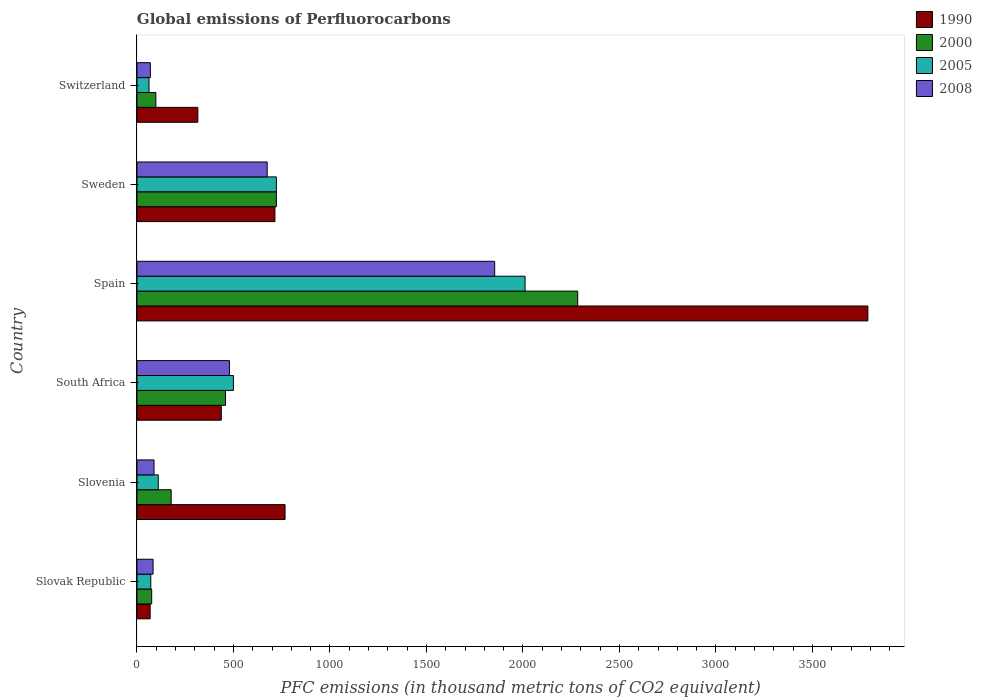How many groups of bars are there?
Your answer should be compact. 6. Are the number of bars per tick equal to the number of legend labels?
Ensure brevity in your answer.  Yes. Are the number of bars on each tick of the Y-axis equal?
Your answer should be compact. Yes. How many bars are there on the 1st tick from the top?
Provide a short and direct response. 4. How many bars are there on the 3rd tick from the bottom?
Provide a short and direct response. 4. In how many cases, is the number of bars for a given country not equal to the number of legend labels?
Provide a short and direct response. 0. What is the global emissions of Perfluorocarbons in 2005 in Slovenia?
Keep it short and to the point. 110.3. Across all countries, what is the maximum global emissions of Perfluorocarbons in 2005?
Offer a terse response. 2011. Across all countries, what is the minimum global emissions of Perfluorocarbons in 2008?
Make the answer very short. 69.4. In which country was the global emissions of Perfluorocarbons in 2008 minimum?
Provide a short and direct response. Switzerland. What is the total global emissions of Perfluorocarbons in 2008 in the graph?
Your answer should be compact. 3248.8. What is the difference between the global emissions of Perfluorocarbons in 1990 in South Africa and that in Sweden?
Your answer should be very brief. -277.9. What is the difference between the global emissions of Perfluorocarbons in 2005 in Sweden and the global emissions of Perfluorocarbons in 1990 in Slovak Republic?
Give a very brief answer. 654. What is the average global emissions of Perfluorocarbons in 1990 per country?
Your answer should be compact. 1015.08. What is the difference between the global emissions of Perfluorocarbons in 2005 and global emissions of Perfluorocarbons in 2000 in Switzerland?
Your response must be concise. -35.4. In how many countries, is the global emissions of Perfluorocarbons in 2008 greater than 3300 thousand metric tons?
Provide a short and direct response. 0. What is the ratio of the global emissions of Perfluorocarbons in 2005 in Slovak Republic to that in Slovenia?
Offer a terse response. 0.65. Is the global emissions of Perfluorocarbons in 2008 in Slovenia less than that in Spain?
Provide a succinct answer. Yes. What is the difference between the highest and the second highest global emissions of Perfluorocarbons in 2005?
Offer a very short reply. 1288.7. What is the difference between the highest and the lowest global emissions of Perfluorocarbons in 2005?
Offer a terse response. 1948.5. Is the sum of the global emissions of Perfluorocarbons in 2008 in Slovak Republic and Spain greater than the maximum global emissions of Perfluorocarbons in 1990 across all countries?
Give a very brief answer. No. What does the 1st bar from the bottom in Slovak Republic represents?
Make the answer very short. 1990. How many bars are there?
Make the answer very short. 24. Are all the bars in the graph horizontal?
Provide a short and direct response. Yes. How many countries are there in the graph?
Your response must be concise. 6. What is the difference between two consecutive major ticks on the X-axis?
Your answer should be very brief. 500. Does the graph contain any zero values?
Your answer should be very brief. No. How many legend labels are there?
Make the answer very short. 4. How are the legend labels stacked?
Keep it short and to the point. Vertical. What is the title of the graph?
Ensure brevity in your answer.  Global emissions of Perfluorocarbons. Does "2012" appear as one of the legend labels in the graph?
Provide a succinct answer. No. What is the label or title of the X-axis?
Offer a terse response. PFC emissions (in thousand metric tons of CO2 equivalent). What is the label or title of the Y-axis?
Make the answer very short. Country. What is the PFC emissions (in thousand metric tons of CO2 equivalent) of 1990 in Slovak Republic?
Offer a terse response. 68.3. What is the PFC emissions (in thousand metric tons of CO2 equivalent) in 2000 in Slovak Republic?
Give a very brief answer. 76.3. What is the PFC emissions (in thousand metric tons of CO2 equivalent) of 2005 in Slovak Republic?
Make the answer very short. 71.6. What is the PFC emissions (in thousand metric tons of CO2 equivalent) in 2008 in Slovak Republic?
Your answer should be very brief. 83.5. What is the PFC emissions (in thousand metric tons of CO2 equivalent) in 1990 in Slovenia?
Ensure brevity in your answer.  767.4. What is the PFC emissions (in thousand metric tons of CO2 equivalent) in 2000 in Slovenia?
Your answer should be very brief. 177.2. What is the PFC emissions (in thousand metric tons of CO2 equivalent) of 2005 in Slovenia?
Your response must be concise. 110.3. What is the PFC emissions (in thousand metric tons of CO2 equivalent) in 2008 in Slovenia?
Make the answer very short. 88.4. What is the PFC emissions (in thousand metric tons of CO2 equivalent) of 1990 in South Africa?
Your answer should be compact. 437. What is the PFC emissions (in thousand metric tons of CO2 equivalent) of 2000 in South Africa?
Offer a terse response. 458.8. What is the PFC emissions (in thousand metric tons of CO2 equivalent) of 2005 in South Africa?
Offer a very short reply. 499.8. What is the PFC emissions (in thousand metric tons of CO2 equivalent) in 2008 in South Africa?
Make the answer very short. 479.2. What is the PFC emissions (in thousand metric tons of CO2 equivalent) of 1990 in Spain?
Keep it short and to the point. 3787.4. What is the PFC emissions (in thousand metric tons of CO2 equivalent) in 2000 in Spain?
Make the answer very short. 2283.8. What is the PFC emissions (in thousand metric tons of CO2 equivalent) of 2005 in Spain?
Your answer should be compact. 2011. What is the PFC emissions (in thousand metric tons of CO2 equivalent) of 2008 in Spain?
Give a very brief answer. 1853.5. What is the PFC emissions (in thousand metric tons of CO2 equivalent) in 1990 in Sweden?
Provide a short and direct response. 714.9. What is the PFC emissions (in thousand metric tons of CO2 equivalent) in 2000 in Sweden?
Provide a short and direct response. 722.5. What is the PFC emissions (in thousand metric tons of CO2 equivalent) of 2005 in Sweden?
Keep it short and to the point. 722.3. What is the PFC emissions (in thousand metric tons of CO2 equivalent) in 2008 in Sweden?
Offer a terse response. 674.8. What is the PFC emissions (in thousand metric tons of CO2 equivalent) in 1990 in Switzerland?
Your answer should be compact. 315.5. What is the PFC emissions (in thousand metric tons of CO2 equivalent) of 2000 in Switzerland?
Offer a terse response. 97.9. What is the PFC emissions (in thousand metric tons of CO2 equivalent) of 2005 in Switzerland?
Make the answer very short. 62.5. What is the PFC emissions (in thousand metric tons of CO2 equivalent) of 2008 in Switzerland?
Your answer should be compact. 69.4. Across all countries, what is the maximum PFC emissions (in thousand metric tons of CO2 equivalent) in 1990?
Offer a terse response. 3787.4. Across all countries, what is the maximum PFC emissions (in thousand metric tons of CO2 equivalent) of 2000?
Give a very brief answer. 2283.8. Across all countries, what is the maximum PFC emissions (in thousand metric tons of CO2 equivalent) of 2005?
Your answer should be very brief. 2011. Across all countries, what is the maximum PFC emissions (in thousand metric tons of CO2 equivalent) in 2008?
Give a very brief answer. 1853.5. Across all countries, what is the minimum PFC emissions (in thousand metric tons of CO2 equivalent) in 1990?
Your answer should be very brief. 68.3. Across all countries, what is the minimum PFC emissions (in thousand metric tons of CO2 equivalent) in 2000?
Your answer should be very brief. 76.3. Across all countries, what is the minimum PFC emissions (in thousand metric tons of CO2 equivalent) in 2005?
Provide a succinct answer. 62.5. Across all countries, what is the minimum PFC emissions (in thousand metric tons of CO2 equivalent) in 2008?
Offer a very short reply. 69.4. What is the total PFC emissions (in thousand metric tons of CO2 equivalent) of 1990 in the graph?
Your answer should be very brief. 6090.5. What is the total PFC emissions (in thousand metric tons of CO2 equivalent) in 2000 in the graph?
Ensure brevity in your answer.  3816.5. What is the total PFC emissions (in thousand metric tons of CO2 equivalent) of 2005 in the graph?
Make the answer very short. 3477.5. What is the total PFC emissions (in thousand metric tons of CO2 equivalent) in 2008 in the graph?
Ensure brevity in your answer.  3248.8. What is the difference between the PFC emissions (in thousand metric tons of CO2 equivalent) of 1990 in Slovak Republic and that in Slovenia?
Offer a very short reply. -699.1. What is the difference between the PFC emissions (in thousand metric tons of CO2 equivalent) in 2000 in Slovak Republic and that in Slovenia?
Give a very brief answer. -100.9. What is the difference between the PFC emissions (in thousand metric tons of CO2 equivalent) of 2005 in Slovak Republic and that in Slovenia?
Make the answer very short. -38.7. What is the difference between the PFC emissions (in thousand metric tons of CO2 equivalent) of 1990 in Slovak Republic and that in South Africa?
Make the answer very short. -368.7. What is the difference between the PFC emissions (in thousand metric tons of CO2 equivalent) of 2000 in Slovak Republic and that in South Africa?
Your response must be concise. -382.5. What is the difference between the PFC emissions (in thousand metric tons of CO2 equivalent) in 2005 in Slovak Republic and that in South Africa?
Your answer should be very brief. -428.2. What is the difference between the PFC emissions (in thousand metric tons of CO2 equivalent) of 2008 in Slovak Republic and that in South Africa?
Ensure brevity in your answer.  -395.7. What is the difference between the PFC emissions (in thousand metric tons of CO2 equivalent) of 1990 in Slovak Republic and that in Spain?
Offer a terse response. -3719.1. What is the difference between the PFC emissions (in thousand metric tons of CO2 equivalent) of 2000 in Slovak Republic and that in Spain?
Offer a terse response. -2207.5. What is the difference between the PFC emissions (in thousand metric tons of CO2 equivalent) of 2005 in Slovak Republic and that in Spain?
Offer a terse response. -1939.4. What is the difference between the PFC emissions (in thousand metric tons of CO2 equivalent) in 2008 in Slovak Republic and that in Spain?
Ensure brevity in your answer.  -1770. What is the difference between the PFC emissions (in thousand metric tons of CO2 equivalent) of 1990 in Slovak Republic and that in Sweden?
Offer a very short reply. -646.6. What is the difference between the PFC emissions (in thousand metric tons of CO2 equivalent) of 2000 in Slovak Republic and that in Sweden?
Offer a very short reply. -646.2. What is the difference between the PFC emissions (in thousand metric tons of CO2 equivalent) in 2005 in Slovak Republic and that in Sweden?
Offer a very short reply. -650.7. What is the difference between the PFC emissions (in thousand metric tons of CO2 equivalent) in 2008 in Slovak Republic and that in Sweden?
Your response must be concise. -591.3. What is the difference between the PFC emissions (in thousand metric tons of CO2 equivalent) in 1990 in Slovak Republic and that in Switzerland?
Offer a very short reply. -247.2. What is the difference between the PFC emissions (in thousand metric tons of CO2 equivalent) in 2000 in Slovak Republic and that in Switzerland?
Make the answer very short. -21.6. What is the difference between the PFC emissions (in thousand metric tons of CO2 equivalent) in 2008 in Slovak Republic and that in Switzerland?
Provide a short and direct response. 14.1. What is the difference between the PFC emissions (in thousand metric tons of CO2 equivalent) in 1990 in Slovenia and that in South Africa?
Provide a succinct answer. 330.4. What is the difference between the PFC emissions (in thousand metric tons of CO2 equivalent) of 2000 in Slovenia and that in South Africa?
Your response must be concise. -281.6. What is the difference between the PFC emissions (in thousand metric tons of CO2 equivalent) of 2005 in Slovenia and that in South Africa?
Keep it short and to the point. -389.5. What is the difference between the PFC emissions (in thousand metric tons of CO2 equivalent) of 2008 in Slovenia and that in South Africa?
Keep it short and to the point. -390.8. What is the difference between the PFC emissions (in thousand metric tons of CO2 equivalent) of 1990 in Slovenia and that in Spain?
Keep it short and to the point. -3020. What is the difference between the PFC emissions (in thousand metric tons of CO2 equivalent) of 2000 in Slovenia and that in Spain?
Offer a terse response. -2106.6. What is the difference between the PFC emissions (in thousand metric tons of CO2 equivalent) in 2005 in Slovenia and that in Spain?
Give a very brief answer. -1900.7. What is the difference between the PFC emissions (in thousand metric tons of CO2 equivalent) of 2008 in Slovenia and that in Spain?
Keep it short and to the point. -1765.1. What is the difference between the PFC emissions (in thousand metric tons of CO2 equivalent) of 1990 in Slovenia and that in Sweden?
Offer a terse response. 52.5. What is the difference between the PFC emissions (in thousand metric tons of CO2 equivalent) in 2000 in Slovenia and that in Sweden?
Offer a very short reply. -545.3. What is the difference between the PFC emissions (in thousand metric tons of CO2 equivalent) of 2005 in Slovenia and that in Sweden?
Provide a short and direct response. -612. What is the difference between the PFC emissions (in thousand metric tons of CO2 equivalent) of 2008 in Slovenia and that in Sweden?
Provide a succinct answer. -586.4. What is the difference between the PFC emissions (in thousand metric tons of CO2 equivalent) of 1990 in Slovenia and that in Switzerland?
Your answer should be compact. 451.9. What is the difference between the PFC emissions (in thousand metric tons of CO2 equivalent) of 2000 in Slovenia and that in Switzerland?
Your answer should be compact. 79.3. What is the difference between the PFC emissions (in thousand metric tons of CO2 equivalent) of 2005 in Slovenia and that in Switzerland?
Make the answer very short. 47.8. What is the difference between the PFC emissions (in thousand metric tons of CO2 equivalent) in 1990 in South Africa and that in Spain?
Provide a succinct answer. -3350.4. What is the difference between the PFC emissions (in thousand metric tons of CO2 equivalent) of 2000 in South Africa and that in Spain?
Ensure brevity in your answer.  -1825. What is the difference between the PFC emissions (in thousand metric tons of CO2 equivalent) in 2005 in South Africa and that in Spain?
Provide a succinct answer. -1511.2. What is the difference between the PFC emissions (in thousand metric tons of CO2 equivalent) in 2008 in South Africa and that in Spain?
Keep it short and to the point. -1374.3. What is the difference between the PFC emissions (in thousand metric tons of CO2 equivalent) in 1990 in South Africa and that in Sweden?
Offer a very short reply. -277.9. What is the difference between the PFC emissions (in thousand metric tons of CO2 equivalent) of 2000 in South Africa and that in Sweden?
Provide a succinct answer. -263.7. What is the difference between the PFC emissions (in thousand metric tons of CO2 equivalent) in 2005 in South Africa and that in Sweden?
Offer a terse response. -222.5. What is the difference between the PFC emissions (in thousand metric tons of CO2 equivalent) in 2008 in South Africa and that in Sweden?
Offer a terse response. -195.6. What is the difference between the PFC emissions (in thousand metric tons of CO2 equivalent) of 1990 in South Africa and that in Switzerland?
Offer a very short reply. 121.5. What is the difference between the PFC emissions (in thousand metric tons of CO2 equivalent) of 2000 in South Africa and that in Switzerland?
Make the answer very short. 360.9. What is the difference between the PFC emissions (in thousand metric tons of CO2 equivalent) in 2005 in South Africa and that in Switzerland?
Provide a short and direct response. 437.3. What is the difference between the PFC emissions (in thousand metric tons of CO2 equivalent) in 2008 in South Africa and that in Switzerland?
Your response must be concise. 409.8. What is the difference between the PFC emissions (in thousand metric tons of CO2 equivalent) of 1990 in Spain and that in Sweden?
Provide a short and direct response. 3072.5. What is the difference between the PFC emissions (in thousand metric tons of CO2 equivalent) in 2000 in Spain and that in Sweden?
Provide a succinct answer. 1561.3. What is the difference between the PFC emissions (in thousand metric tons of CO2 equivalent) in 2005 in Spain and that in Sweden?
Your response must be concise. 1288.7. What is the difference between the PFC emissions (in thousand metric tons of CO2 equivalent) of 2008 in Spain and that in Sweden?
Offer a very short reply. 1178.7. What is the difference between the PFC emissions (in thousand metric tons of CO2 equivalent) of 1990 in Spain and that in Switzerland?
Your answer should be compact. 3471.9. What is the difference between the PFC emissions (in thousand metric tons of CO2 equivalent) in 2000 in Spain and that in Switzerland?
Your answer should be compact. 2185.9. What is the difference between the PFC emissions (in thousand metric tons of CO2 equivalent) of 2005 in Spain and that in Switzerland?
Ensure brevity in your answer.  1948.5. What is the difference between the PFC emissions (in thousand metric tons of CO2 equivalent) in 2008 in Spain and that in Switzerland?
Your answer should be very brief. 1784.1. What is the difference between the PFC emissions (in thousand metric tons of CO2 equivalent) of 1990 in Sweden and that in Switzerland?
Provide a short and direct response. 399.4. What is the difference between the PFC emissions (in thousand metric tons of CO2 equivalent) of 2000 in Sweden and that in Switzerland?
Provide a succinct answer. 624.6. What is the difference between the PFC emissions (in thousand metric tons of CO2 equivalent) of 2005 in Sweden and that in Switzerland?
Provide a short and direct response. 659.8. What is the difference between the PFC emissions (in thousand metric tons of CO2 equivalent) in 2008 in Sweden and that in Switzerland?
Your answer should be compact. 605.4. What is the difference between the PFC emissions (in thousand metric tons of CO2 equivalent) of 1990 in Slovak Republic and the PFC emissions (in thousand metric tons of CO2 equivalent) of 2000 in Slovenia?
Provide a succinct answer. -108.9. What is the difference between the PFC emissions (in thousand metric tons of CO2 equivalent) in 1990 in Slovak Republic and the PFC emissions (in thousand metric tons of CO2 equivalent) in 2005 in Slovenia?
Your answer should be very brief. -42. What is the difference between the PFC emissions (in thousand metric tons of CO2 equivalent) in 1990 in Slovak Republic and the PFC emissions (in thousand metric tons of CO2 equivalent) in 2008 in Slovenia?
Your response must be concise. -20.1. What is the difference between the PFC emissions (in thousand metric tons of CO2 equivalent) in 2000 in Slovak Republic and the PFC emissions (in thousand metric tons of CO2 equivalent) in 2005 in Slovenia?
Offer a very short reply. -34. What is the difference between the PFC emissions (in thousand metric tons of CO2 equivalent) in 2005 in Slovak Republic and the PFC emissions (in thousand metric tons of CO2 equivalent) in 2008 in Slovenia?
Your answer should be compact. -16.8. What is the difference between the PFC emissions (in thousand metric tons of CO2 equivalent) in 1990 in Slovak Republic and the PFC emissions (in thousand metric tons of CO2 equivalent) in 2000 in South Africa?
Make the answer very short. -390.5. What is the difference between the PFC emissions (in thousand metric tons of CO2 equivalent) of 1990 in Slovak Republic and the PFC emissions (in thousand metric tons of CO2 equivalent) of 2005 in South Africa?
Offer a very short reply. -431.5. What is the difference between the PFC emissions (in thousand metric tons of CO2 equivalent) of 1990 in Slovak Republic and the PFC emissions (in thousand metric tons of CO2 equivalent) of 2008 in South Africa?
Offer a terse response. -410.9. What is the difference between the PFC emissions (in thousand metric tons of CO2 equivalent) of 2000 in Slovak Republic and the PFC emissions (in thousand metric tons of CO2 equivalent) of 2005 in South Africa?
Offer a terse response. -423.5. What is the difference between the PFC emissions (in thousand metric tons of CO2 equivalent) of 2000 in Slovak Republic and the PFC emissions (in thousand metric tons of CO2 equivalent) of 2008 in South Africa?
Offer a terse response. -402.9. What is the difference between the PFC emissions (in thousand metric tons of CO2 equivalent) in 2005 in Slovak Republic and the PFC emissions (in thousand metric tons of CO2 equivalent) in 2008 in South Africa?
Offer a terse response. -407.6. What is the difference between the PFC emissions (in thousand metric tons of CO2 equivalent) in 1990 in Slovak Republic and the PFC emissions (in thousand metric tons of CO2 equivalent) in 2000 in Spain?
Your response must be concise. -2215.5. What is the difference between the PFC emissions (in thousand metric tons of CO2 equivalent) of 1990 in Slovak Republic and the PFC emissions (in thousand metric tons of CO2 equivalent) of 2005 in Spain?
Keep it short and to the point. -1942.7. What is the difference between the PFC emissions (in thousand metric tons of CO2 equivalent) of 1990 in Slovak Republic and the PFC emissions (in thousand metric tons of CO2 equivalent) of 2008 in Spain?
Give a very brief answer. -1785.2. What is the difference between the PFC emissions (in thousand metric tons of CO2 equivalent) in 2000 in Slovak Republic and the PFC emissions (in thousand metric tons of CO2 equivalent) in 2005 in Spain?
Your answer should be very brief. -1934.7. What is the difference between the PFC emissions (in thousand metric tons of CO2 equivalent) of 2000 in Slovak Republic and the PFC emissions (in thousand metric tons of CO2 equivalent) of 2008 in Spain?
Ensure brevity in your answer.  -1777.2. What is the difference between the PFC emissions (in thousand metric tons of CO2 equivalent) of 2005 in Slovak Republic and the PFC emissions (in thousand metric tons of CO2 equivalent) of 2008 in Spain?
Give a very brief answer. -1781.9. What is the difference between the PFC emissions (in thousand metric tons of CO2 equivalent) in 1990 in Slovak Republic and the PFC emissions (in thousand metric tons of CO2 equivalent) in 2000 in Sweden?
Keep it short and to the point. -654.2. What is the difference between the PFC emissions (in thousand metric tons of CO2 equivalent) in 1990 in Slovak Republic and the PFC emissions (in thousand metric tons of CO2 equivalent) in 2005 in Sweden?
Offer a terse response. -654. What is the difference between the PFC emissions (in thousand metric tons of CO2 equivalent) in 1990 in Slovak Republic and the PFC emissions (in thousand metric tons of CO2 equivalent) in 2008 in Sweden?
Your answer should be very brief. -606.5. What is the difference between the PFC emissions (in thousand metric tons of CO2 equivalent) of 2000 in Slovak Republic and the PFC emissions (in thousand metric tons of CO2 equivalent) of 2005 in Sweden?
Offer a terse response. -646. What is the difference between the PFC emissions (in thousand metric tons of CO2 equivalent) of 2000 in Slovak Republic and the PFC emissions (in thousand metric tons of CO2 equivalent) of 2008 in Sweden?
Ensure brevity in your answer.  -598.5. What is the difference between the PFC emissions (in thousand metric tons of CO2 equivalent) of 2005 in Slovak Republic and the PFC emissions (in thousand metric tons of CO2 equivalent) of 2008 in Sweden?
Make the answer very short. -603.2. What is the difference between the PFC emissions (in thousand metric tons of CO2 equivalent) in 1990 in Slovak Republic and the PFC emissions (in thousand metric tons of CO2 equivalent) in 2000 in Switzerland?
Ensure brevity in your answer.  -29.6. What is the difference between the PFC emissions (in thousand metric tons of CO2 equivalent) of 1990 in Slovak Republic and the PFC emissions (in thousand metric tons of CO2 equivalent) of 2008 in Switzerland?
Provide a short and direct response. -1.1. What is the difference between the PFC emissions (in thousand metric tons of CO2 equivalent) of 2000 in Slovak Republic and the PFC emissions (in thousand metric tons of CO2 equivalent) of 2005 in Switzerland?
Offer a very short reply. 13.8. What is the difference between the PFC emissions (in thousand metric tons of CO2 equivalent) of 2000 in Slovak Republic and the PFC emissions (in thousand metric tons of CO2 equivalent) of 2008 in Switzerland?
Your answer should be compact. 6.9. What is the difference between the PFC emissions (in thousand metric tons of CO2 equivalent) in 2005 in Slovak Republic and the PFC emissions (in thousand metric tons of CO2 equivalent) in 2008 in Switzerland?
Offer a terse response. 2.2. What is the difference between the PFC emissions (in thousand metric tons of CO2 equivalent) in 1990 in Slovenia and the PFC emissions (in thousand metric tons of CO2 equivalent) in 2000 in South Africa?
Offer a terse response. 308.6. What is the difference between the PFC emissions (in thousand metric tons of CO2 equivalent) in 1990 in Slovenia and the PFC emissions (in thousand metric tons of CO2 equivalent) in 2005 in South Africa?
Provide a succinct answer. 267.6. What is the difference between the PFC emissions (in thousand metric tons of CO2 equivalent) of 1990 in Slovenia and the PFC emissions (in thousand metric tons of CO2 equivalent) of 2008 in South Africa?
Your answer should be compact. 288.2. What is the difference between the PFC emissions (in thousand metric tons of CO2 equivalent) of 2000 in Slovenia and the PFC emissions (in thousand metric tons of CO2 equivalent) of 2005 in South Africa?
Your answer should be very brief. -322.6. What is the difference between the PFC emissions (in thousand metric tons of CO2 equivalent) of 2000 in Slovenia and the PFC emissions (in thousand metric tons of CO2 equivalent) of 2008 in South Africa?
Offer a terse response. -302. What is the difference between the PFC emissions (in thousand metric tons of CO2 equivalent) in 2005 in Slovenia and the PFC emissions (in thousand metric tons of CO2 equivalent) in 2008 in South Africa?
Offer a terse response. -368.9. What is the difference between the PFC emissions (in thousand metric tons of CO2 equivalent) of 1990 in Slovenia and the PFC emissions (in thousand metric tons of CO2 equivalent) of 2000 in Spain?
Give a very brief answer. -1516.4. What is the difference between the PFC emissions (in thousand metric tons of CO2 equivalent) of 1990 in Slovenia and the PFC emissions (in thousand metric tons of CO2 equivalent) of 2005 in Spain?
Ensure brevity in your answer.  -1243.6. What is the difference between the PFC emissions (in thousand metric tons of CO2 equivalent) of 1990 in Slovenia and the PFC emissions (in thousand metric tons of CO2 equivalent) of 2008 in Spain?
Your answer should be very brief. -1086.1. What is the difference between the PFC emissions (in thousand metric tons of CO2 equivalent) in 2000 in Slovenia and the PFC emissions (in thousand metric tons of CO2 equivalent) in 2005 in Spain?
Provide a short and direct response. -1833.8. What is the difference between the PFC emissions (in thousand metric tons of CO2 equivalent) in 2000 in Slovenia and the PFC emissions (in thousand metric tons of CO2 equivalent) in 2008 in Spain?
Your answer should be very brief. -1676.3. What is the difference between the PFC emissions (in thousand metric tons of CO2 equivalent) of 2005 in Slovenia and the PFC emissions (in thousand metric tons of CO2 equivalent) of 2008 in Spain?
Keep it short and to the point. -1743.2. What is the difference between the PFC emissions (in thousand metric tons of CO2 equivalent) of 1990 in Slovenia and the PFC emissions (in thousand metric tons of CO2 equivalent) of 2000 in Sweden?
Provide a short and direct response. 44.9. What is the difference between the PFC emissions (in thousand metric tons of CO2 equivalent) of 1990 in Slovenia and the PFC emissions (in thousand metric tons of CO2 equivalent) of 2005 in Sweden?
Offer a very short reply. 45.1. What is the difference between the PFC emissions (in thousand metric tons of CO2 equivalent) of 1990 in Slovenia and the PFC emissions (in thousand metric tons of CO2 equivalent) of 2008 in Sweden?
Provide a short and direct response. 92.6. What is the difference between the PFC emissions (in thousand metric tons of CO2 equivalent) in 2000 in Slovenia and the PFC emissions (in thousand metric tons of CO2 equivalent) in 2005 in Sweden?
Make the answer very short. -545.1. What is the difference between the PFC emissions (in thousand metric tons of CO2 equivalent) of 2000 in Slovenia and the PFC emissions (in thousand metric tons of CO2 equivalent) of 2008 in Sweden?
Your response must be concise. -497.6. What is the difference between the PFC emissions (in thousand metric tons of CO2 equivalent) of 2005 in Slovenia and the PFC emissions (in thousand metric tons of CO2 equivalent) of 2008 in Sweden?
Offer a terse response. -564.5. What is the difference between the PFC emissions (in thousand metric tons of CO2 equivalent) of 1990 in Slovenia and the PFC emissions (in thousand metric tons of CO2 equivalent) of 2000 in Switzerland?
Offer a terse response. 669.5. What is the difference between the PFC emissions (in thousand metric tons of CO2 equivalent) in 1990 in Slovenia and the PFC emissions (in thousand metric tons of CO2 equivalent) in 2005 in Switzerland?
Provide a succinct answer. 704.9. What is the difference between the PFC emissions (in thousand metric tons of CO2 equivalent) in 1990 in Slovenia and the PFC emissions (in thousand metric tons of CO2 equivalent) in 2008 in Switzerland?
Ensure brevity in your answer.  698. What is the difference between the PFC emissions (in thousand metric tons of CO2 equivalent) in 2000 in Slovenia and the PFC emissions (in thousand metric tons of CO2 equivalent) in 2005 in Switzerland?
Offer a terse response. 114.7. What is the difference between the PFC emissions (in thousand metric tons of CO2 equivalent) in 2000 in Slovenia and the PFC emissions (in thousand metric tons of CO2 equivalent) in 2008 in Switzerland?
Keep it short and to the point. 107.8. What is the difference between the PFC emissions (in thousand metric tons of CO2 equivalent) of 2005 in Slovenia and the PFC emissions (in thousand metric tons of CO2 equivalent) of 2008 in Switzerland?
Provide a succinct answer. 40.9. What is the difference between the PFC emissions (in thousand metric tons of CO2 equivalent) of 1990 in South Africa and the PFC emissions (in thousand metric tons of CO2 equivalent) of 2000 in Spain?
Your answer should be very brief. -1846.8. What is the difference between the PFC emissions (in thousand metric tons of CO2 equivalent) in 1990 in South Africa and the PFC emissions (in thousand metric tons of CO2 equivalent) in 2005 in Spain?
Ensure brevity in your answer.  -1574. What is the difference between the PFC emissions (in thousand metric tons of CO2 equivalent) in 1990 in South Africa and the PFC emissions (in thousand metric tons of CO2 equivalent) in 2008 in Spain?
Your answer should be compact. -1416.5. What is the difference between the PFC emissions (in thousand metric tons of CO2 equivalent) of 2000 in South Africa and the PFC emissions (in thousand metric tons of CO2 equivalent) of 2005 in Spain?
Your answer should be compact. -1552.2. What is the difference between the PFC emissions (in thousand metric tons of CO2 equivalent) in 2000 in South Africa and the PFC emissions (in thousand metric tons of CO2 equivalent) in 2008 in Spain?
Make the answer very short. -1394.7. What is the difference between the PFC emissions (in thousand metric tons of CO2 equivalent) of 2005 in South Africa and the PFC emissions (in thousand metric tons of CO2 equivalent) of 2008 in Spain?
Give a very brief answer. -1353.7. What is the difference between the PFC emissions (in thousand metric tons of CO2 equivalent) in 1990 in South Africa and the PFC emissions (in thousand metric tons of CO2 equivalent) in 2000 in Sweden?
Offer a very short reply. -285.5. What is the difference between the PFC emissions (in thousand metric tons of CO2 equivalent) of 1990 in South Africa and the PFC emissions (in thousand metric tons of CO2 equivalent) of 2005 in Sweden?
Make the answer very short. -285.3. What is the difference between the PFC emissions (in thousand metric tons of CO2 equivalent) of 1990 in South Africa and the PFC emissions (in thousand metric tons of CO2 equivalent) of 2008 in Sweden?
Make the answer very short. -237.8. What is the difference between the PFC emissions (in thousand metric tons of CO2 equivalent) of 2000 in South Africa and the PFC emissions (in thousand metric tons of CO2 equivalent) of 2005 in Sweden?
Your response must be concise. -263.5. What is the difference between the PFC emissions (in thousand metric tons of CO2 equivalent) in 2000 in South Africa and the PFC emissions (in thousand metric tons of CO2 equivalent) in 2008 in Sweden?
Your response must be concise. -216. What is the difference between the PFC emissions (in thousand metric tons of CO2 equivalent) of 2005 in South Africa and the PFC emissions (in thousand metric tons of CO2 equivalent) of 2008 in Sweden?
Offer a very short reply. -175. What is the difference between the PFC emissions (in thousand metric tons of CO2 equivalent) in 1990 in South Africa and the PFC emissions (in thousand metric tons of CO2 equivalent) in 2000 in Switzerland?
Make the answer very short. 339.1. What is the difference between the PFC emissions (in thousand metric tons of CO2 equivalent) of 1990 in South Africa and the PFC emissions (in thousand metric tons of CO2 equivalent) of 2005 in Switzerland?
Make the answer very short. 374.5. What is the difference between the PFC emissions (in thousand metric tons of CO2 equivalent) in 1990 in South Africa and the PFC emissions (in thousand metric tons of CO2 equivalent) in 2008 in Switzerland?
Provide a succinct answer. 367.6. What is the difference between the PFC emissions (in thousand metric tons of CO2 equivalent) of 2000 in South Africa and the PFC emissions (in thousand metric tons of CO2 equivalent) of 2005 in Switzerland?
Provide a succinct answer. 396.3. What is the difference between the PFC emissions (in thousand metric tons of CO2 equivalent) of 2000 in South Africa and the PFC emissions (in thousand metric tons of CO2 equivalent) of 2008 in Switzerland?
Make the answer very short. 389.4. What is the difference between the PFC emissions (in thousand metric tons of CO2 equivalent) in 2005 in South Africa and the PFC emissions (in thousand metric tons of CO2 equivalent) in 2008 in Switzerland?
Ensure brevity in your answer.  430.4. What is the difference between the PFC emissions (in thousand metric tons of CO2 equivalent) of 1990 in Spain and the PFC emissions (in thousand metric tons of CO2 equivalent) of 2000 in Sweden?
Give a very brief answer. 3064.9. What is the difference between the PFC emissions (in thousand metric tons of CO2 equivalent) in 1990 in Spain and the PFC emissions (in thousand metric tons of CO2 equivalent) in 2005 in Sweden?
Your response must be concise. 3065.1. What is the difference between the PFC emissions (in thousand metric tons of CO2 equivalent) in 1990 in Spain and the PFC emissions (in thousand metric tons of CO2 equivalent) in 2008 in Sweden?
Your response must be concise. 3112.6. What is the difference between the PFC emissions (in thousand metric tons of CO2 equivalent) of 2000 in Spain and the PFC emissions (in thousand metric tons of CO2 equivalent) of 2005 in Sweden?
Your answer should be very brief. 1561.5. What is the difference between the PFC emissions (in thousand metric tons of CO2 equivalent) in 2000 in Spain and the PFC emissions (in thousand metric tons of CO2 equivalent) in 2008 in Sweden?
Ensure brevity in your answer.  1609. What is the difference between the PFC emissions (in thousand metric tons of CO2 equivalent) in 2005 in Spain and the PFC emissions (in thousand metric tons of CO2 equivalent) in 2008 in Sweden?
Your answer should be compact. 1336.2. What is the difference between the PFC emissions (in thousand metric tons of CO2 equivalent) of 1990 in Spain and the PFC emissions (in thousand metric tons of CO2 equivalent) of 2000 in Switzerland?
Give a very brief answer. 3689.5. What is the difference between the PFC emissions (in thousand metric tons of CO2 equivalent) of 1990 in Spain and the PFC emissions (in thousand metric tons of CO2 equivalent) of 2005 in Switzerland?
Make the answer very short. 3724.9. What is the difference between the PFC emissions (in thousand metric tons of CO2 equivalent) in 1990 in Spain and the PFC emissions (in thousand metric tons of CO2 equivalent) in 2008 in Switzerland?
Give a very brief answer. 3718. What is the difference between the PFC emissions (in thousand metric tons of CO2 equivalent) in 2000 in Spain and the PFC emissions (in thousand metric tons of CO2 equivalent) in 2005 in Switzerland?
Provide a succinct answer. 2221.3. What is the difference between the PFC emissions (in thousand metric tons of CO2 equivalent) of 2000 in Spain and the PFC emissions (in thousand metric tons of CO2 equivalent) of 2008 in Switzerland?
Your response must be concise. 2214.4. What is the difference between the PFC emissions (in thousand metric tons of CO2 equivalent) in 2005 in Spain and the PFC emissions (in thousand metric tons of CO2 equivalent) in 2008 in Switzerland?
Offer a terse response. 1941.6. What is the difference between the PFC emissions (in thousand metric tons of CO2 equivalent) in 1990 in Sweden and the PFC emissions (in thousand metric tons of CO2 equivalent) in 2000 in Switzerland?
Give a very brief answer. 617. What is the difference between the PFC emissions (in thousand metric tons of CO2 equivalent) in 1990 in Sweden and the PFC emissions (in thousand metric tons of CO2 equivalent) in 2005 in Switzerland?
Make the answer very short. 652.4. What is the difference between the PFC emissions (in thousand metric tons of CO2 equivalent) in 1990 in Sweden and the PFC emissions (in thousand metric tons of CO2 equivalent) in 2008 in Switzerland?
Provide a succinct answer. 645.5. What is the difference between the PFC emissions (in thousand metric tons of CO2 equivalent) in 2000 in Sweden and the PFC emissions (in thousand metric tons of CO2 equivalent) in 2005 in Switzerland?
Make the answer very short. 660. What is the difference between the PFC emissions (in thousand metric tons of CO2 equivalent) in 2000 in Sweden and the PFC emissions (in thousand metric tons of CO2 equivalent) in 2008 in Switzerland?
Your answer should be compact. 653.1. What is the difference between the PFC emissions (in thousand metric tons of CO2 equivalent) in 2005 in Sweden and the PFC emissions (in thousand metric tons of CO2 equivalent) in 2008 in Switzerland?
Give a very brief answer. 652.9. What is the average PFC emissions (in thousand metric tons of CO2 equivalent) in 1990 per country?
Offer a very short reply. 1015.08. What is the average PFC emissions (in thousand metric tons of CO2 equivalent) in 2000 per country?
Offer a terse response. 636.08. What is the average PFC emissions (in thousand metric tons of CO2 equivalent) in 2005 per country?
Offer a terse response. 579.58. What is the average PFC emissions (in thousand metric tons of CO2 equivalent) in 2008 per country?
Your response must be concise. 541.47. What is the difference between the PFC emissions (in thousand metric tons of CO2 equivalent) in 1990 and PFC emissions (in thousand metric tons of CO2 equivalent) in 2000 in Slovak Republic?
Your answer should be compact. -8. What is the difference between the PFC emissions (in thousand metric tons of CO2 equivalent) in 1990 and PFC emissions (in thousand metric tons of CO2 equivalent) in 2008 in Slovak Republic?
Ensure brevity in your answer.  -15.2. What is the difference between the PFC emissions (in thousand metric tons of CO2 equivalent) of 2000 and PFC emissions (in thousand metric tons of CO2 equivalent) of 2008 in Slovak Republic?
Give a very brief answer. -7.2. What is the difference between the PFC emissions (in thousand metric tons of CO2 equivalent) in 2005 and PFC emissions (in thousand metric tons of CO2 equivalent) in 2008 in Slovak Republic?
Give a very brief answer. -11.9. What is the difference between the PFC emissions (in thousand metric tons of CO2 equivalent) in 1990 and PFC emissions (in thousand metric tons of CO2 equivalent) in 2000 in Slovenia?
Ensure brevity in your answer.  590.2. What is the difference between the PFC emissions (in thousand metric tons of CO2 equivalent) in 1990 and PFC emissions (in thousand metric tons of CO2 equivalent) in 2005 in Slovenia?
Your answer should be compact. 657.1. What is the difference between the PFC emissions (in thousand metric tons of CO2 equivalent) in 1990 and PFC emissions (in thousand metric tons of CO2 equivalent) in 2008 in Slovenia?
Your answer should be compact. 679. What is the difference between the PFC emissions (in thousand metric tons of CO2 equivalent) in 2000 and PFC emissions (in thousand metric tons of CO2 equivalent) in 2005 in Slovenia?
Give a very brief answer. 66.9. What is the difference between the PFC emissions (in thousand metric tons of CO2 equivalent) in 2000 and PFC emissions (in thousand metric tons of CO2 equivalent) in 2008 in Slovenia?
Your answer should be very brief. 88.8. What is the difference between the PFC emissions (in thousand metric tons of CO2 equivalent) of 2005 and PFC emissions (in thousand metric tons of CO2 equivalent) of 2008 in Slovenia?
Your response must be concise. 21.9. What is the difference between the PFC emissions (in thousand metric tons of CO2 equivalent) of 1990 and PFC emissions (in thousand metric tons of CO2 equivalent) of 2000 in South Africa?
Your answer should be compact. -21.8. What is the difference between the PFC emissions (in thousand metric tons of CO2 equivalent) of 1990 and PFC emissions (in thousand metric tons of CO2 equivalent) of 2005 in South Africa?
Offer a very short reply. -62.8. What is the difference between the PFC emissions (in thousand metric tons of CO2 equivalent) in 1990 and PFC emissions (in thousand metric tons of CO2 equivalent) in 2008 in South Africa?
Your answer should be compact. -42.2. What is the difference between the PFC emissions (in thousand metric tons of CO2 equivalent) of 2000 and PFC emissions (in thousand metric tons of CO2 equivalent) of 2005 in South Africa?
Your answer should be compact. -41. What is the difference between the PFC emissions (in thousand metric tons of CO2 equivalent) in 2000 and PFC emissions (in thousand metric tons of CO2 equivalent) in 2008 in South Africa?
Keep it short and to the point. -20.4. What is the difference between the PFC emissions (in thousand metric tons of CO2 equivalent) of 2005 and PFC emissions (in thousand metric tons of CO2 equivalent) of 2008 in South Africa?
Keep it short and to the point. 20.6. What is the difference between the PFC emissions (in thousand metric tons of CO2 equivalent) in 1990 and PFC emissions (in thousand metric tons of CO2 equivalent) in 2000 in Spain?
Your answer should be compact. 1503.6. What is the difference between the PFC emissions (in thousand metric tons of CO2 equivalent) in 1990 and PFC emissions (in thousand metric tons of CO2 equivalent) in 2005 in Spain?
Give a very brief answer. 1776.4. What is the difference between the PFC emissions (in thousand metric tons of CO2 equivalent) of 1990 and PFC emissions (in thousand metric tons of CO2 equivalent) of 2008 in Spain?
Your response must be concise. 1933.9. What is the difference between the PFC emissions (in thousand metric tons of CO2 equivalent) of 2000 and PFC emissions (in thousand metric tons of CO2 equivalent) of 2005 in Spain?
Make the answer very short. 272.8. What is the difference between the PFC emissions (in thousand metric tons of CO2 equivalent) in 2000 and PFC emissions (in thousand metric tons of CO2 equivalent) in 2008 in Spain?
Keep it short and to the point. 430.3. What is the difference between the PFC emissions (in thousand metric tons of CO2 equivalent) of 2005 and PFC emissions (in thousand metric tons of CO2 equivalent) of 2008 in Spain?
Your answer should be compact. 157.5. What is the difference between the PFC emissions (in thousand metric tons of CO2 equivalent) of 1990 and PFC emissions (in thousand metric tons of CO2 equivalent) of 2000 in Sweden?
Your response must be concise. -7.6. What is the difference between the PFC emissions (in thousand metric tons of CO2 equivalent) of 1990 and PFC emissions (in thousand metric tons of CO2 equivalent) of 2008 in Sweden?
Provide a succinct answer. 40.1. What is the difference between the PFC emissions (in thousand metric tons of CO2 equivalent) in 2000 and PFC emissions (in thousand metric tons of CO2 equivalent) in 2008 in Sweden?
Your answer should be compact. 47.7. What is the difference between the PFC emissions (in thousand metric tons of CO2 equivalent) of 2005 and PFC emissions (in thousand metric tons of CO2 equivalent) of 2008 in Sweden?
Offer a very short reply. 47.5. What is the difference between the PFC emissions (in thousand metric tons of CO2 equivalent) of 1990 and PFC emissions (in thousand metric tons of CO2 equivalent) of 2000 in Switzerland?
Your answer should be compact. 217.6. What is the difference between the PFC emissions (in thousand metric tons of CO2 equivalent) of 1990 and PFC emissions (in thousand metric tons of CO2 equivalent) of 2005 in Switzerland?
Provide a succinct answer. 253. What is the difference between the PFC emissions (in thousand metric tons of CO2 equivalent) in 1990 and PFC emissions (in thousand metric tons of CO2 equivalent) in 2008 in Switzerland?
Provide a short and direct response. 246.1. What is the difference between the PFC emissions (in thousand metric tons of CO2 equivalent) in 2000 and PFC emissions (in thousand metric tons of CO2 equivalent) in 2005 in Switzerland?
Offer a very short reply. 35.4. What is the ratio of the PFC emissions (in thousand metric tons of CO2 equivalent) of 1990 in Slovak Republic to that in Slovenia?
Provide a succinct answer. 0.09. What is the ratio of the PFC emissions (in thousand metric tons of CO2 equivalent) in 2000 in Slovak Republic to that in Slovenia?
Make the answer very short. 0.43. What is the ratio of the PFC emissions (in thousand metric tons of CO2 equivalent) in 2005 in Slovak Republic to that in Slovenia?
Offer a terse response. 0.65. What is the ratio of the PFC emissions (in thousand metric tons of CO2 equivalent) in 2008 in Slovak Republic to that in Slovenia?
Provide a short and direct response. 0.94. What is the ratio of the PFC emissions (in thousand metric tons of CO2 equivalent) of 1990 in Slovak Republic to that in South Africa?
Your answer should be compact. 0.16. What is the ratio of the PFC emissions (in thousand metric tons of CO2 equivalent) of 2000 in Slovak Republic to that in South Africa?
Provide a succinct answer. 0.17. What is the ratio of the PFC emissions (in thousand metric tons of CO2 equivalent) in 2005 in Slovak Republic to that in South Africa?
Your answer should be very brief. 0.14. What is the ratio of the PFC emissions (in thousand metric tons of CO2 equivalent) of 2008 in Slovak Republic to that in South Africa?
Make the answer very short. 0.17. What is the ratio of the PFC emissions (in thousand metric tons of CO2 equivalent) in 1990 in Slovak Republic to that in Spain?
Offer a terse response. 0.02. What is the ratio of the PFC emissions (in thousand metric tons of CO2 equivalent) in 2000 in Slovak Republic to that in Spain?
Give a very brief answer. 0.03. What is the ratio of the PFC emissions (in thousand metric tons of CO2 equivalent) of 2005 in Slovak Republic to that in Spain?
Offer a terse response. 0.04. What is the ratio of the PFC emissions (in thousand metric tons of CO2 equivalent) in 2008 in Slovak Republic to that in Spain?
Make the answer very short. 0.04. What is the ratio of the PFC emissions (in thousand metric tons of CO2 equivalent) in 1990 in Slovak Republic to that in Sweden?
Make the answer very short. 0.1. What is the ratio of the PFC emissions (in thousand metric tons of CO2 equivalent) of 2000 in Slovak Republic to that in Sweden?
Give a very brief answer. 0.11. What is the ratio of the PFC emissions (in thousand metric tons of CO2 equivalent) of 2005 in Slovak Republic to that in Sweden?
Offer a terse response. 0.1. What is the ratio of the PFC emissions (in thousand metric tons of CO2 equivalent) of 2008 in Slovak Republic to that in Sweden?
Offer a very short reply. 0.12. What is the ratio of the PFC emissions (in thousand metric tons of CO2 equivalent) in 1990 in Slovak Republic to that in Switzerland?
Give a very brief answer. 0.22. What is the ratio of the PFC emissions (in thousand metric tons of CO2 equivalent) of 2000 in Slovak Republic to that in Switzerland?
Make the answer very short. 0.78. What is the ratio of the PFC emissions (in thousand metric tons of CO2 equivalent) of 2005 in Slovak Republic to that in Switzerland?
Make the answer very short. 1.15. What is the ratio of the PFC emissions (in thousand metric tons of CO2 equivalent) of 2008 in Slovak Republic to that in Switzerland?
Make the answer very short. 1.2. What is the ratio of the PFC emissions (in thousand metric tons of CO2 equivalent) in 1990 in Slovenia to that in South Africa?
Offer a very short reply. 1.76. What is the ratio of the PFC emissions (in thousand metric tons of CO2 equivalent) of 2000 in Slovenia to that in South Africa?
Ensure brevity in your answer.  0.39. What is the ratio of the PFC emissions (in thousand metric tons of CO2 equivalent) in 2005 in Slovenia to that in South Africa?
Provide a short and direct response. 0.22. What is the ratio of the PFC emissions (in thousand metric tons of CO2 equivalent) in 2008 in Slovenia to that in South Africa?
Your answer should be very brief. 0.18. What is the ratio of the PFC emissions (in thousand metric tons of CO2 equivalent) of 1990 in Slovenia to that in Spain?
Your answer should be compact. 0.2. What is the ratio of the PFC emissions (in thousand metric tons of CO2 equivalent) in 2000 in Slovenia to that in Spain?
Provide a succinct answer. 0.08. What is the ratio of the PFC emissions (in thousand metric tons of CO2 equivalent) of 2005 in Slovenia to that in Spain?
Provide a short and direct response. 0.05. What is the ratio of the PFC emissions (in thousand metric tons of CO2 equivalent) in 2008 in Slovenia to that in Spain?
Give a very brief answer. 0.05. What is the ratio of the PFC emissions (in thousand metric tons of CO2 equivalent) of 1990 in Slovenia to that in Sweden?
Your answer should be compact. 1.07. What is the ratio of the PFC emissions (in thousand metric tons of CO2 equivalent) of 2000 in Slovenia to that in Sweden?
Your answer should be very brief. 0.25. What is the ratio of the PFC emissions (in thousand metric tons of CO2 equivalent) in 2005 in Slovenia to that in Sweden?
Your response must be concise. 0.15. What is the ratio of the PFC emissions (in thousand metric tons of CO2 equivalent) in 2008 in Slovenia to that in Sweden?
Your answer should be compact. 0.13. What is the ratio of the PFC emissions (in thousand metric tons of CO2 equivalent) in 1990 in Slovenia to that in Switzerland?
Provide a succinct answer. 2.43. What is the ratio of the PFC emissions (in thousand metric tons of CO2 equivalent) of 2000 in Slovenia to that in Switzerland?
Give a very brief answer. 1.81. What is the ratio of the PFC emissions (in thousand metric tons of CO2 equivalent) in 2005 in Slovenia to that in Switzerland?
Your answer should be compact. 1.76. What is the ratio of the PFC emissions (in thousand metric tons of CO2 equivalent) of 2008 in Slovenia to that in Switzerland?
Your answer should be very brief. 1.27. What is the ratio of the PFC emissions (in thousand metric tons of CO2 equivalent) of 1990 in South Africa to that in Spain?
Give a very brief answer. 0.12. What is the ratio of the PFC emissions (in thousand metric tons of CO2 equivalent) of 2000 in South Africa to that in Spain?
Keep it short and to the point. 0.2. What is the ratio of the PFC emissions (in thousand metric tons of CO2 equivalent) in 2005 in South Africa to that in Spain?
Make the answer very short. 0.25. What is the ratio of the PFC emissions (in thousand metric tons of CO2 equivalent) in 2008 in South Africa to that in Spain?
Provide a short and direct response. 0.26. What is the ratio of the PFC emissions (in thousand metric tons of CO2 equivalent) of 1990 in South Africa to that in Sweden?
Keep it short and to the point. 0.61. What is the ratio of the PFC emissions (in thousand metric tons of CO2 equivalent) in 2000 in South Africa to that in Sweden?
Make the answer very short. 0.64. What is the ratio of the PFC emissions (in thousand metric tons of CO2 equivalent) of 2005 in South Africa to that in Sweden?
Offer a very short reply. 0.69. What is the ratio of the PFC emissions (in thousand metric tons of CO2 equivalent) in 2008 in South Africa to that in Sweden?
Offer a terse response. 0.71. What is the ratio of the PFC emissions (in thousand metric tons of CO2 equivalent) of 1990 in South Africa to that in Switzerland?
Your response must be concise. 1.39. What is the ratio of the PFC emissions (in thousand metric tons of CO2 equivalent) in 2000 in South Africa to that in Switzerland?
Ensure brevity in your answer.  4.69. What is the ratio of the PFC emissions (in thousand metric tons of CO2 equivalent) in 2005 in South Africa to that in Switzerland?
Make the answer very short. 8. What is the ratio of the PFC emissions (in thousand metric tons of CO2 equivalent) of 2008 in South Africa to that in Switzerland?
Your answer should be compact. 6.9. What is the ratio of the PFC emissions (in thousand metric tons of CO2 equivalent) of 1990 in Spain to that in Sweden?
Make the answer very short. 5.3. What is the ratio of the PFC emissions (in thousand metric tons of CO2 equivalent) in 2000 in Spain to that in Sweden?
Your answer should be compact. 3.16. What is the ratio of the PFC emissions (in thousand metric tons of CO2 equivalent) of 2005 in Spain to that in Sweden?
Ensure brevity in your answer.  2.78. What is the ratio of the PFC emissions (in thousand metric tons of CO2 equivalent) in 2008 in Spain to that in Sweden?
Your answer should be compact. 2.75. What is the ratio of the PFC emissions (in thousand metric tons of CO2 equivalent) of 1990 in Spain to that in Switzerland?
Offer a terse response. 12. What is the ratio of the PFC emissions (in thousand metric tons of CO2 equivalent) of 2000 in Spain to that in Switzerland?
Keep it short and to the point. 23.33. What is the ratio of the PFC emissions (in thousand metric tons of CO2 equivalent) of 2005 in Spain to that in Switzerland?
Make the answer very short. 32.18. What is the ratio of the PFC emissions (in thousand metric tons of CO2 equivalent) of 2008 in Spain to that in Switzerland?
Your answer should be very brief. 26.71. What is the ratio of the PFC emissions (in thousand metric tons of CO2 equivalent) in 1990 in Sweden to that in Switzerland?
Ensure brevity in your answer.  2.27. What is the ratio of the PFC emissions (in thousand metric tons of CO2 equivalent) in 2000 in Sweden to that in Switzerland?
Give a very brief answer. 7.38. What is the ratio of the PFC emissions (in thousand metric tons of CO2 equivalent) of 2005 in Sweden to that in Switzerland?
Provide a succinct answer. 11.56. What is the ratio of the PFC emissions (in thousand metric tons of CO2 equivalent) in 2008 in Sweden to that in Switzerland?
Ensure brevity in your answer.  9.72. What is the difference between the highest and the second highest PFC emissions (in thousand metric tons of CO2 equivalent) of 1990?
Give a very brief answer. 3020. What is the difference between the highest and the second highest PFC emissions (in thousand metric tons of CO2 equivalent) in 2000?
Your answer should be very brief. 1561.3. What is the difference between the highest and the second highest PFC emissions (in thousand metric tons of CO2 equivalent) of 2005?
Your response must be concise. 1288.7. What is the difference between the highest and the second highest PFC emissions (in thousand metric tons of CO2 equivalent) in 2008?
Ensure brevity in your answer.  1178.7. What is the difference between the highest and the lowest PFC emissions (in thousand metric tons of CO2 equivalent) of 1990?
Offer a terse response. 3719.1. What is the difference between the highest and the lowest PFC emissions (in thousand metric tons of CO2 equivalent) in 2000?
Offer a terse response. 2207.5. What is the difference between the highest and the lowest PFC emissions (in thousand metric tons of CO2 equivalent) in 2005?
Your answer should be compact. 1948.5. What is the difference between the highest and the lowest PFC emissions (in thousand metric tons of CO2 equivalent) of 2008?
Give a very brief answer. 1784.1. 